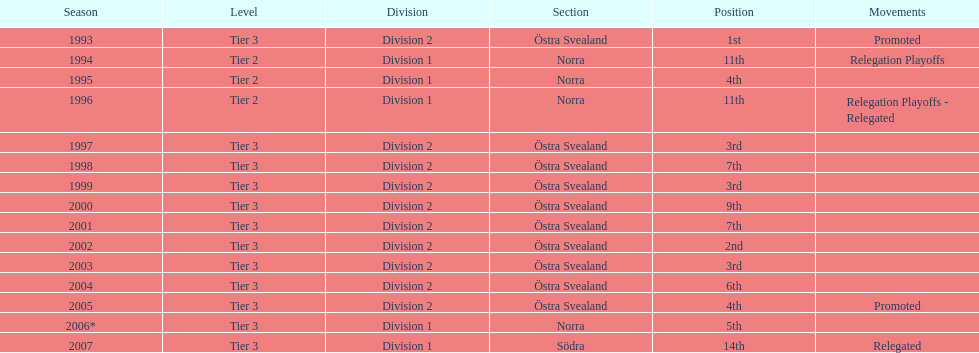What year is at least on the list? 2007. 